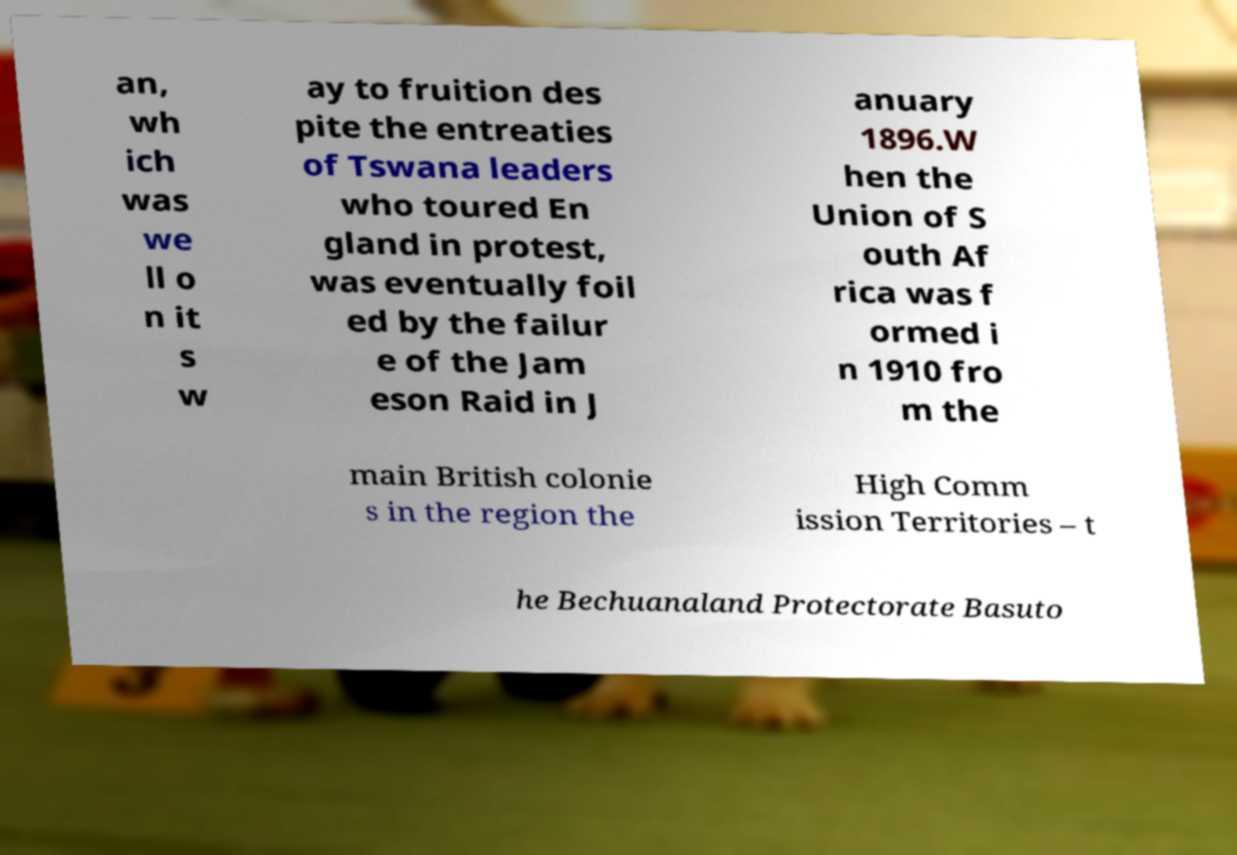Could you extract and type out the text from this image? an, wh ich was we ll o n it s w ay to fruition des pite the entreaties of Tswana leaders who toured En gland in protest, was eventually foil ed by the failur e of the Jam eson Raid in J anuary 1896.W hen the Union of S outh Af rica was f ormed i n 1910 fro m the main British colonie s in the region the High Comm ission Territories – t he Bechuanaland Protectorate Basuto 